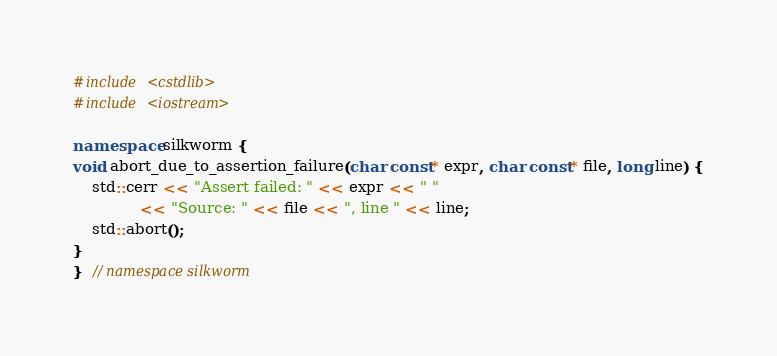<code> <loc_0><loc_0><loc_500><loc_500><_C++_>
#include <cstdlib>
#include <iostream>

namespace silkworm {
void abort_due_to_assertion_failure(char const* expr, char const* file, long line) {
    std::cerr << "Assert failed: " << expr << " "
              << "Source: " << file << ", line " << line;
    std::abort();
}
}  // namespace silkworm
</code> 